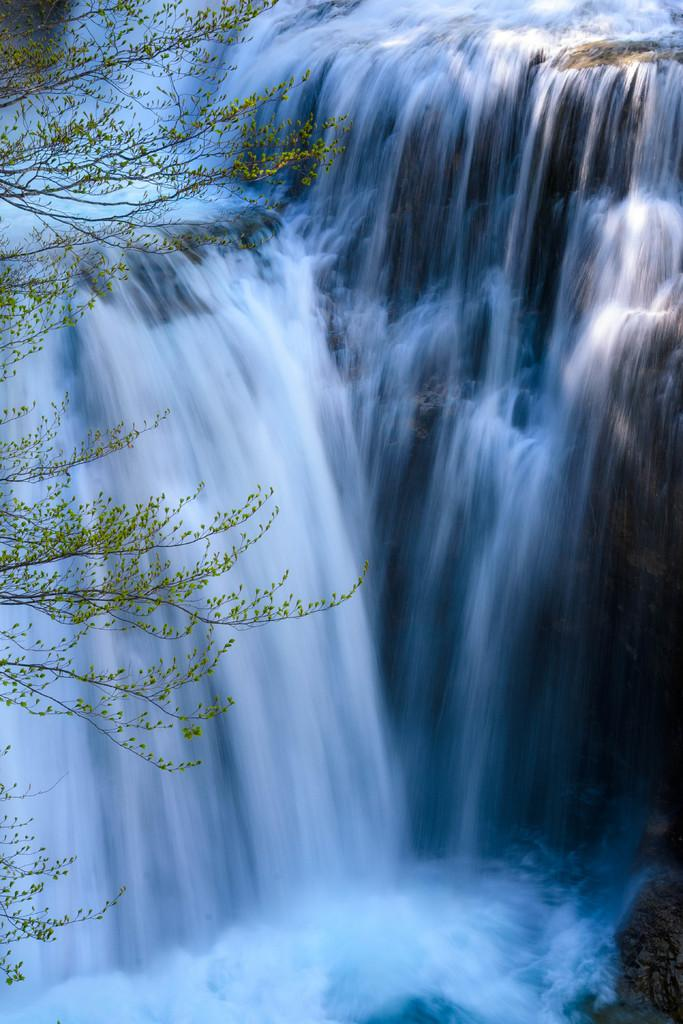What natural feature is present in the image? There is a waterfall in the image. What type of vegetation can be seen in the image? There are trees in the image. What type of apple is being used to create the art piece in the image? There is no apple or art piece present in the image; it features a waterfall and trees. 